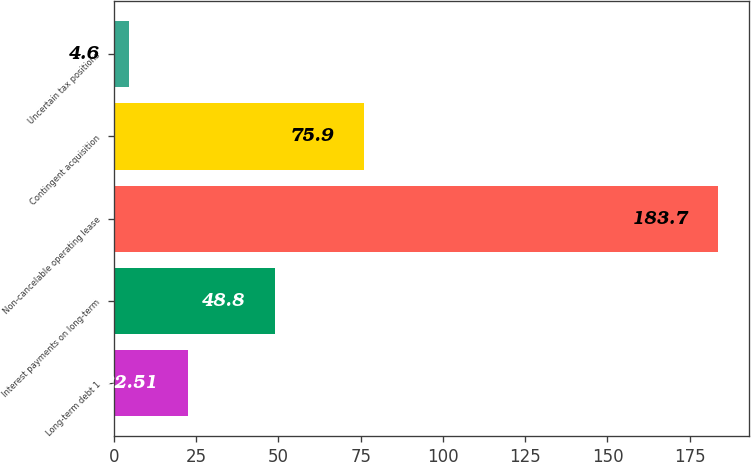Convert chart to OTSL. <chart><loc_0><loc_0><loc_500><loc_500><bar_chart><fcel>Long-term debt 1<fcel>Interest payments on long-term<fcel>Non-cancelable operating lease<fcel>Contingent acquisition<fcel>Uncertain tax positions<nl><fcel>22.51<fcel>48.8<fcel>183.7<fcel>75.9<fcel>4.6<nl></chart> 